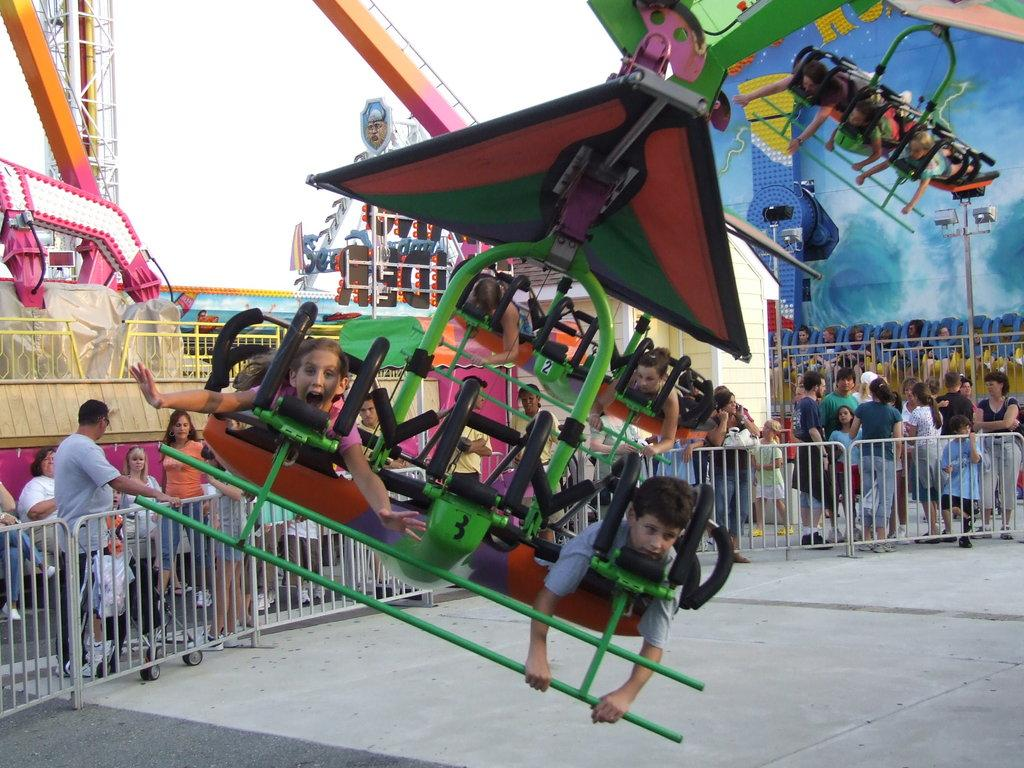What are the children doing in the image? The children are playing in the image. Where are the people standing in relation to the children? The people are standing near fencing in the image. What are the people doing while standing near the fencing? The people are watching the children play. What type of insect can be seen crawling on the children in the image? There are no insects visible in the image, and therefore no insects are crawling on the children. 